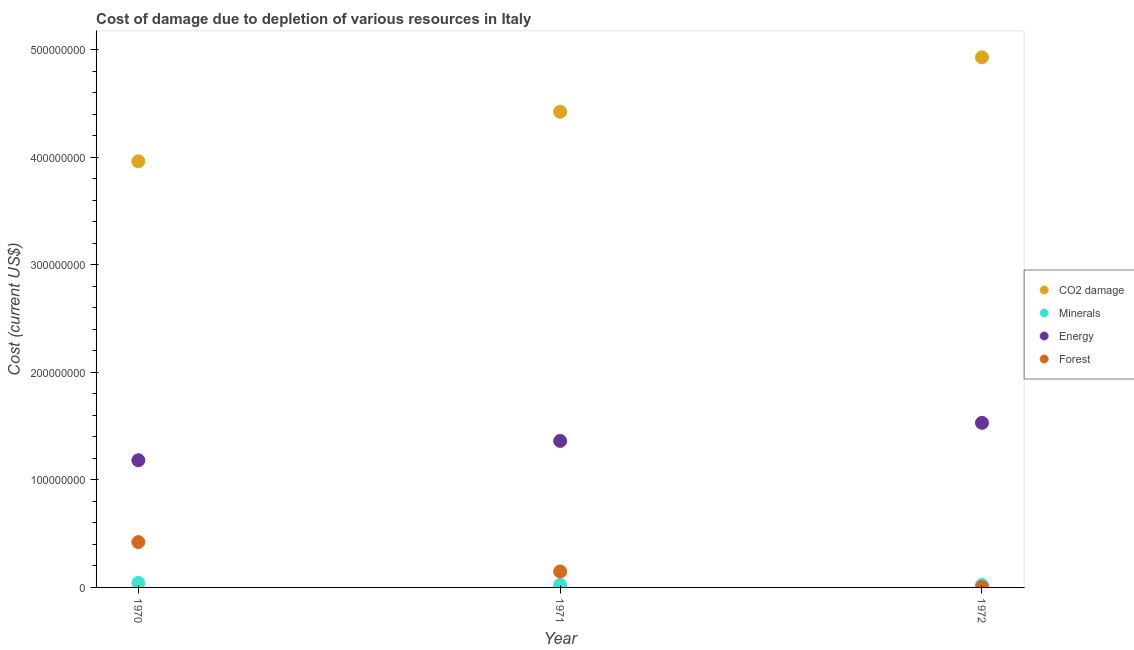How many different coloured dotlines are there?
Your answer should be very brief. 4. Is the number of dotlines equal to the number of legend labels?
Keep it short and to the point. Yes. What is the cost of damage due to depletion of minerals in 1971?
Your response must be concise. 2.28e+06. Across all years, what is the maximum cost of damage due to depletion of energy?
Provide a succinct answer. 1.53e+08. Across all years, what is the minimum cost of damage due to depletion of coal?
Your response must be concise. 3.96e+08. What is the total cost of damage due to depletion of coal in the graph?
Your answer should be compact. 1.33e+09. What is the difference between the cost of damage due to depletion of minerals in 1970 and that in 1971?
Offer a terse response. 1.89e+06. What is the difference between the cost of damage due to depletion of coal in 1970 and the cost of damage due to depletion of minerals in 1971?
Provide a succinct answer. 3.94e+08. What is the average cost of damage due to depletion of coal per year?
Your response must be concise. 4.44e+08. In the year 1970, what is the difference between the cost of damage due to depletion of minerals and cost of damage due to depletion of energy?
Your answer should be very brief. -1.14e+08. In how many years, is the cost of damage due to depletion of minerals greater than 360000000 US$?
Make the answer very short. 0. What is the ratio of the cost of damage due to depletion of minerals in 1970 to that in 1971?
Give a very brief answer. 1.83. Is the difference between the cost of damage due to depletion of forests in 1971 and 1972 greater than the difference between the cost of damage due to depletion of energy in 1971 and 1972?
Ensure brevity in your answer.  Yes. What is the difference between the highest and the second highest cost of damage due to depletion of energy?
Provide a succinct answer. 1.68e+07. What is the difference between the highest and the lowest cost of damage due to depletion of energy?
Offer a very short reply. 3.48e+07. Is it the case that in every year, the sum of the cost of damage due to depletion of coal and cost of damage due to depletion of energy is greater than the sum of cost of damage due to depletion of forests and cost of damage due to depletion of minerals?
Give a very brief answer. Yes. Is the cost of damage due to depletion of coal strictly greater than the cost of damage due to depletion of energy over the years?
Provide a short and direct response. Yes. How many dotlines are there?
Your response must be concise. 4. What is the difference between two consecutive major ticks on the Y-axis?
Your answer should be compact. 1.00e+08. Does the graph contain any zero values?
Your answer should be very brief. No. Does the graph contain grids?
Keep it short and to the point. No. Where does the legend appear in the graph?
Your answer should be very brief. Center right. What is the title of the graph?
Provide a succinct answer. Cost of damage due to depletion of various resources in Italy . Does "Trade" appear as one of the legend labels in the graph?
Provide a short and direct response. No. What is the label or title of the X-axis?
Your answer should be very brief. Year. What is the label or title of the Y-axis?
Provide a short and direct response. Cost (current US$). What is the Cost (current US$) of CO2 damage in 1970?
Make the answer very short. 3.96e+08. What is the Cost (current US$) in Minerals in 1970?
Your answer should be very brief. 4.17e+06. What is the Cost (current US$) in Energy in 1970?
Provide a succinct answer. 1.18e+08. What is the Cost (current US$) in Forest in 1970?
Provide a short and direct response. 4.22e+07. What is the Cost (current US$) in CO2 damage in 1971?
Your answer should be compact. 4.42e+08. What is the Cost (current US$) in Minerals in 1971?
Your response must be concise. 2.28e+06. What is the Cost (current US$) of Energy in 1971?
Make the answer very short. 1.36e+08. What is the Cost (current US$) of Forest in 1971?
Give a very brief answer. 1.48e+07. What is the Cost (current US$) in CO2 damage in 1972?
Make the answer very short. 4.93e+08. What is the Cost (current US$) in Minerals in 1972?
Provide a short and direct response. 2.32e+06. What is the Cost (current US$) in Energy in 1972?
Provide a succinct answer. 1.53e+08. What is the Cost (current US$) of Forest in 1972?
Make the answer very short. 3.87e+05. Across all years, what is the maximum Cost (current US$) in CO2 damage?
Keep it short and to the point. 4.93e+08. Across all years, what is the maximum Cost (current US$) in Minerals?
Make the answer very short. 4.17e+06. Across all years, what is the maximum Cost (current US$) in Energy?
Offer a very short reply. 1.53e+08. Across all years, what is the maximum Cost (current US$) in Forest?
Provide a short and direct response. 4.22e+07. Across all years, what is the minimum Cost (current US$) in CO2 damage?
Provide a short and direct response. 3.96e+08. Across all years, what is the minimum Cost (current US$) of Minerals?
Keep it short and to the point. 2.28e+06. Across all years, what is the minimum Cost (current US$) in Energy?
Give a very brief answer. 1.18e+08. Across all years, what is the minimum Cost (current US$) of Forest?
Offer a terse response. 3.87e+05. What is the total Cost (current US$) in CO2 damage in the graph?
Offer a very short reply. 1.33e+09. What is the total Cost (current US$) in Minerals in the graph?
Make the answer very short. 8.77e+06. What is the total Cost (current US$) of Energy in the graph?
Your answer should be very brief. 4.07e+08. What is the total Cost (current US$) of Forest in the graph?
Offer a terse response. 5.73e+07. What is the difference between the Cost (current US$) of CO2 damage in 1970 and that in 1971?
Provide a succinct answer. -4.61e+07. What is the difference between the Cost (current US$) in Minerals in 1970 and that in 1971?
Your answer should be compact. 1.89e+06. What is the difference between the Cost (current US$) in Energy in 1970 and that in 1971?
Ensure brevity in your answer.  -1.80e+07. What is the difference between the Cost (current US$) in Forest in 1970 and that in 1971?
Your response must be concise. 2.74e+07. What is the difference between the Cost (current US$) in CO2 damage in 1970 and that in 1972?
Make the answer very short. -9.67e+07. What is the difference between the Cost (current US$) of Minerals in 1970 and that in 1972?
Your answer should be very brief. 1.86e+06. What is the difference between the Cost (current US$) of Energy in 1970 and that in 1972?
Your answer should be very brief. -3.48e+07. What is the difference between the Cost (current US$) in Forest in 1970 and that in 1972?
Offer a very short reply. 4.18e+07. What is the difference between the Cost (current US$) in CO2 damage in 1971 and that in 1972?
Your answer should be compact. -5.06e+07. What is the difference between the Cost (current US$) in Minerals in 1971 and that in 1972?
Keep it short and to the point. -3.72e+04. What is the difference between the Cost (current US$) in Energy in 1971 and that in 1972?
Make the answer very short. -1.68e+07. What is the difference between the Cost (current US$) of Forest in 1971 and that in 1972?
Give a very brief answer. 1.44e+07. What is the difference between the Cost (current US$) in CO2 damage in 1970 and the Cost (current US$) in Minerals in 1971?
Give a very brief answer. 3.94e+08. What is the difference between the Cost (current US$) in CO2 damage in 1970 and the Cost (current US$) in Energy in 1971?
Offer a very short reply. 2.60e+08. What is the difference between the Cost (current US$) in CO2 damage in 1970 and the Cost (current US$) in Forest in 1971?
Provide a short and direct response. 3.81e+08. What is the difference between the Cost (current US$) in Minerals in 1970 and the Cost (current US$) in Energy in 1971?
Provide a succinct answer. -1.32e+08. What is the difference between the Cost (current US$) in Minerals in 1970 and the Cost (current US$) in Forest in 1971?
Your answer should be very brief. -1.06e+07. What is the difference between the Cost (current US$) in Energy in 1970 and the Cost (current US$) in Forest in 1971?
Your response must be concise. 1.03e+08. What is the difference between the Cost (current US$) in CO2 damage in 1970 and the Cost (current US$) in Minerals in 1972?
Provide a short and direct response. 3.94e+08. What is the difference between the Cost (current US$) in CO2 damage in 1970 and the Cost (current US$) in Energy in 1972?
Offer a very short reply. 2.43e+08. What is the difference between the Cost (current US$) in CO2 damage in 1970 and the Cost (current US$) in Forest in 1972?
Your answer should be very brief. 3.96e+08. What is the difference between the Cost (current US$) of Minerals in 1970 and the Cost (current US$) of Energy in 1972?
Offer a terse response. -1.49e+08. What is the difference between the Cost (current US$) of Minerals in 1970 and the Cost (current US$) of Forest in 1972?
Your response must be concise. 3.79e+06. What is the difference between the Cost (current US$) in Energy in 1970 and the Cost (current US$) in Forest in 1972?
Your response must be concise. 1.18e+08. What is the difference between the Cost (current US$) of CO2 damage in 1971 and the Cost (current US$) of Minerals in 1972?
Give a very brief answer. 4.40e+08. What is the difference between the Cost (current US$) of CO2 damage in 1971 and the Cost (current US$) of Energy in 1972?
Make the answer very short. 2.89e+08. What is the difference between the Cost (current US$) in CO2 damage in 1971 and the Cost (current US$) in Forest in 1972?
Offer a very short reply. 4.42e+08. What is the difference between the Cost (current US$) in Minerals in 1971 and the Cost (current US$) in Energy in 1972?
Your answer should be very brief. -1.51e+08. What is the difference between the Cost (current US$) of Minerals in 1971 and the Cost (current US$) of Forest in 1972?
Provide a succinct answer. 1.89e+06. What is the difference between the Cost (current US$) of Energy in 1971 and the Cost (current US$) of Forest in 1972?
Your answer should be compact. 1.36e+08. What is the average Cost (current US$) in CO2 damage per year?
Provide a short and direct response. 4.44e+08. What is the average Cost (current US$) of Minerals per year?
Your answer should be compact. 2.92e+06. What is the average Cost (current US$) of Energy per year?
Offer a terse response. 1.36e+08. What is the average Cost (current US$) in Forest per year?
Ensure brevity in your answer.  1.91e+07. In the year 1970, what is the difference between the Cost (current US$) of CO2 damage and Cost (current US$) of Minerals?
Keep it short and to the point. 3.92e+08. In the year 1970, what is the difference between the Cost (current US$) in CO2 damage and Cost (current US$) in Energy?
Keep it short and to the point. 2.78e+08. In the year 1970, what is the difference between the Cost (current US$) in CO2 damage and Cost (current US$) in Forest?
Your response must be concise. 3.54e+08. In the year 1970, what is the difference between the Cost (current US$) in Minerals and Cost (current US$) in Energy?
Make the answer very short. -1.14e+08. In the year 1970, what is the difference between the Cost (current US$) of Minerals and Cost (current US$) of Forest?
Make the answer very short. -3.80e+07. In the year 1970, what is the difference between the Cost (current US$) in Energy and Cost (current US$) in Forest?
Offer a terse response. 7.61e+07. In the year 1971, what is the difference between the Cost (current US$) of CO2 damage and Cost (current US$) of Minerals?
Provide a succinct answer. 4.40e+08. In the year 1971, what is the difference between the Cost (current US$) in CO2 damage and Cost (current US$) in Energy?
Offer a terse response. 3.06e+08. In the year 1971, what is the difference between the Cost (current US$) of CO2 damage and Cost (current US$) of Forest?
Make the answer very short. 4.27e+08. In the year 1971, what is the difference between the Cost (current US$) of Minerals and Cost (current US$) of Energy?
Provide a short and direct response. -1.34e+08. In the year 1971, what is the difference between the Cost (current US$) of Minerals and Cost (current US$) of Forest?
Keep it short and to the point. -1.25e+07. In the year 1971, what is the difference between the Cost (current US$) in Energy and Cost (current US$) in Forest?
Make the answer very short. 1.21e+08. In the year 1972, what is the difference between the Cost (current US$) in CO2 damage and Cost (current US$) in Minerals?
Your answer should be compact. 4.90e+08. In the year 1972, what is the difference between the Cost (current US$) of CO2 damage and Cost (current US$) of Energy?
Your answer should be compact. 3.40e+08. In the year 1972, what is the difference between the Cost (current US$) of CO2 damage and Cost (current US$) of Forest?
Offer a very short reply. 4.92e+08. In the year 1972, what is the difference between the Cost (current US$) of Minerals and Cost (current US$) of Energy?
Your answer should be very brief. -1.51e+08. In the year 1972, what is the difference between the Cost (current US$) of Minerals and Cost (current US$) of Forest?
Offer a terse response. 1.93e+06. In the year 1972, what is the difference between the Cost (current US$) in Energy and Cost (current US$) in Forest?
Your response must be concise. 1.53e+08. What is the ratio of the Cost (current US$) of CO2 damage in 1970 to that in 1971?
Give a very brief answer. 0.9. What is the ratio of the Cost (current US$) of Minerals in 1970 to that in 1971?
Ensure brevity in your answer.  1.83. What is the ratio of the Cost (current US$) in Energy in 1970 to that in 1971?
Your response must be concise. 0.87. What is the ratio of the Cost (current US$) of Forest in 1970 to that in 1971?
Provide a short and direct response. 2.85. What is the ratio of the Cost (current US$) of CO2 damage in 1970 to that in 1972?
Give a very brief answer. 0.8. What is the ratio of the Cost (current US$) of Minerals in 1970 to that in 1972?
Offer a very short reply. 1.8. What is the ratio of the Cost (current US$) of Energy in 1970 to that in 1972?
Offer a terse response. 0.77. What is the ratio of the Cost (current US$) of Forest in 1970 to that in 1972?
Keep it short and to the point. 108.87. What is the ratio of the Cost (current US$) of CO2 damage in 1971 to that in 1972?
Make the answer very short. 0.9. What is the ratio of the Cost (current US$) in Minerals in 1971 to that in 1972?
Give a very brief answer. 0.98. What is the ratio of the Cost (current US$) in Energy in 1971 to that in 1972?
Give a very brief answer. 0.89. What is the ratio of the Cost (current US$) of Forest in 1971 to that in 1972?
Provide a succinct answer. 38.2. What is the difference between the highest and the second highest Cost (current US$) in CO2 damage?
Your answer should be very brief. 5.06e+07. What is the difference between the highest and the second highest Cost (current US$) of Minerals?
Your response must be concise. 1.86e+06. What is the difference between the highest and the second highest Cost (current US$) of Energy?
Provide a short and direct response. 1.68e+07. What is the difference between the highest and the second highest Cost (current US$) of Forest?
Your response must be concise. 2.74e+07. What is the difference between the highest and the lowest Cost (current US$) in CO2 damage?
Offer a terse response. 9.67e+07. What is the difference between the highest and the lowest Cost (current US$) in Minerals?
Offer a very short reply. 1.89e+06. What is the difference between the highest and the lowest Cost (current US$) of Energy?
Keep it short and to the point. 3.48e+07. What is the difference between the highest and the lowest Cost (current US$) of Forest?
Make the answer very short. 4.18e+07. 